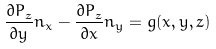<formula> <loc_0><loc_0><loc_500><loc_500>\frac { { \partial P _ { z } } } { \partial y } n _ { x } - \frac { { \partial P _ { z } } } { \partial x } n _ { y } = g ( x , y , z )</formula> 